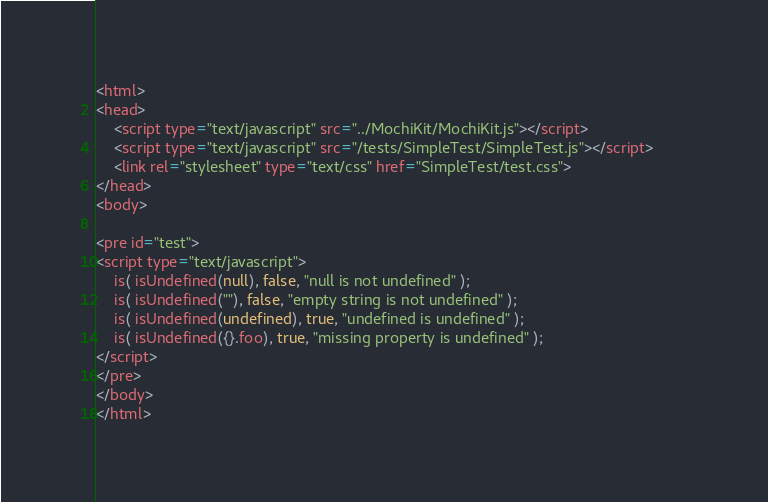<code> <loc_0><loc_0><loc_500><loc_500><_HTML_><html>
<head>
    <script type="text/javascript" src="../MochiKit/MochiKit.js"></script>
    <script type="text/javascript" src="/tests/SimpleTest/SimpleTest.js"></script>        
    <link rel="stylesheet" type="text/css" href="SimpleTest/test.css">
</head>
<body>

<pre id="test">
<script type="text/javascript">
    is( isUndefined(null), false, "null is not undefined" );
    is( isUndefined(""), false, "empty string is not undefined" );
    is( isUndefined(undefined), true, "undefined is undefined" );
    is( isUndefined({}.foo), true, "missing property is undefined" );
</script>
</pre>
</body>
</html>
</code> 